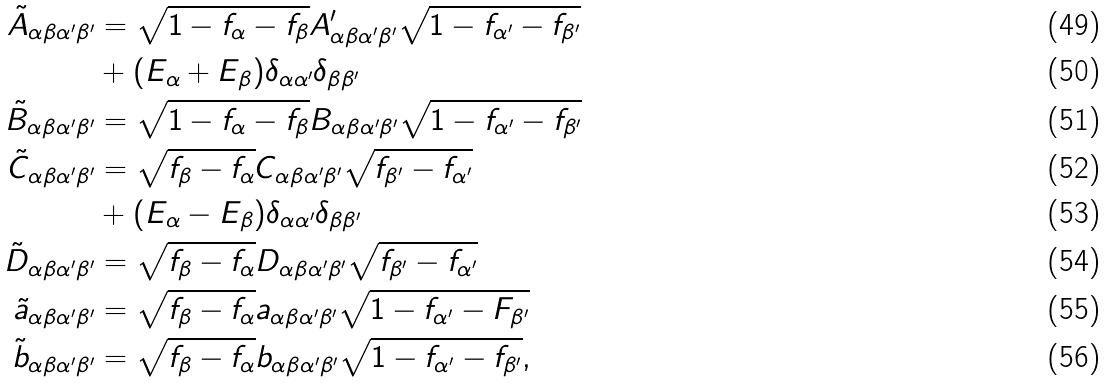<formula> <loc_0><loc_0><loc_500><loc_500>\tilde { A } _ { \alpha \beta \alpha ^ { \prime } \beta ^ { \prime } } & = \sqrt { 1 - f _ { \alpha } - f _ { \beta } } A _ { \alpha \beta \alpha ^ { \prime } \beta ^ { \prime } } ^ { \prime } \sqrt { 1 - f _ { \alpha ^ { \prime } } - f _ { \beta ^ { \prime } } } \\ & + ( E _ { \alpha } + E _ { \beta } ) \delta _ { \alpha \alpha ^ { \prime } } \delta _ { \beta \beta ^ { \prime } } \\ \tilde { B } _ { \alpha \beta \alpha ^ { \prime } \beta ^ { \prime } } & = \sqrt { 1 - f _ { \alpha } - f _ { \beta } } B _ { \alpha \beta \alpha ^ { \prime } \beta ^ { \prime } } \sqrt { 1 - f _ { \alpha ^ { \prime } } - f _ { \beta ^ { \prime } } } \\ \tilde { C } _ { \alpha \beta \alpha ^ { \prime } \beta ^ { \prime } } & = \sqrt { f _ { \beta } - f _ { \alpha } } C _ { \alpha \beta \alpha ^ { \prime } \beta ^ { \prime } } \sqrt { f _ { \beta ^ { \prime } } - f _ { \alpha ^ { \prime } } } \\ & + ( E _ { \alpha } - E _ { \beta } ) \delta _ { \alpha \alpha ^ { \prime } } \delta _ { \beta \beta ^ { \prime } } \\ \tilde { D } _ { \alpha \beta \alpha ^ { \prime } \beta ^ { \prime } } & = \sqrt { f _ { \beta } - f _ { \alpha } } D _ { \alpha \beta \alpha ^ { \prime } \beta ^ { \prime } } \sqrt { f _ { \beta ^ { \prime } } - f _ { \alpha ^ { \prime } } } \\ \tilde { a } _ { \alpha \beta \alpha ^ { \prime } \beta ^ { \prime } } & = \sqrt { f _ { \beta } - f _ { \alpha } } a _ { \alpha \beta \alpha ^ { \prime } \beta ^ { \prime } } \sqrt { 1 - f _ { \alpha ^ { \prime } } - F _ { \beta ^ { \prime } } } \\ \tilde { b } _ { \alpha \beta \alpha ^ { \prime } \beta ^ { \prime } } & = \sqrt { f _ { \beta } - f _ { \alpha } } b _ { \alpha \beta \alpha ^ { \prime } \beta ^ { \prime } } \sqrt { 1 - f _ { \alpha ^ { \prime } } - f _ { \beta ^ { \prime } } } ,</formula> 